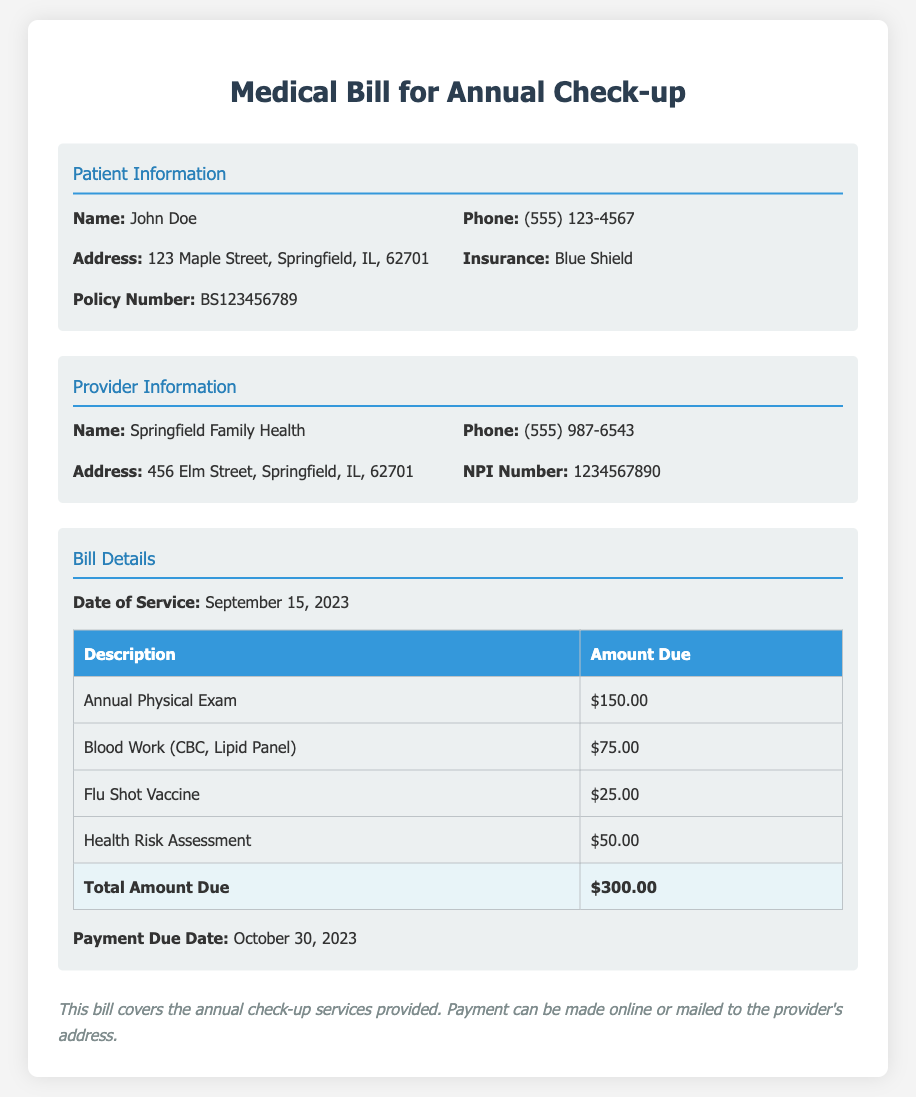What is the patient's name? The name of the patient is specified in the document, which is John Doe.
Answer: John Doe What is the date of service? The document lists the date when the service was provided, which is September 15, 2023.
Answer: September 15, 2023 What is the total amount due? The document clearly states the total amount due for the services rendered is $300.00.
Answer: $300.00 What is the payment due date? The payment due date is mentioned in the bill details section as October 30, 2023.
Answer: October 30, 2023 How many services were rendered? By counting the services listed in the table, which includes four entries, there were four services rendered.
Answer: Four What is the insurance provider's name? The name of the insurance provider is mentioned in the patient information section, which is Blue Shield.
Answer: Blue Shield What type of vaccine was administered? The document specifies that a flu shot vaccine was provided as part of the services.
Answer: Flu Shot Vaccine What is the address of the provider? The address of the provider is included in the document and is 456 Elm Street, Springfield, IL, 62701.
Answer: 456 Elm Street, Springfield, IL, 62701 What is the amount charged for blood work? The amount charged for blood work (CBC, Lipid Panel) is outlined in the services table as $75.00.
Answer: $75.00 What is the phone number of the provider? The phone number for the provider is given in the provider information section, which is (555) 987-6543.
Answer: (555) 987-6543 